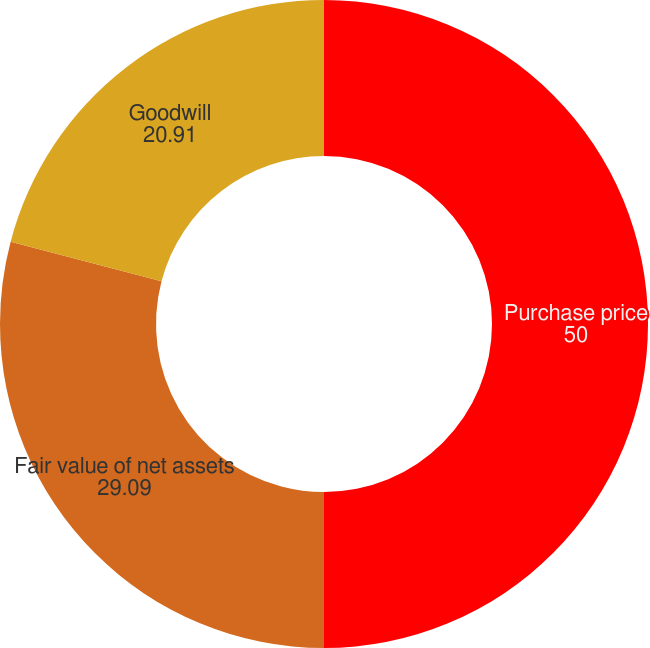<chart> <loc_0><loc_0><loc_500><loc_500><pie_chart><fcel>Purchase price<fcel>Fair value of net assets<fcel>Goodwill<nl><fcel>50.0%<fcel>29.09%<fcel>20.91%<nl></chart> 